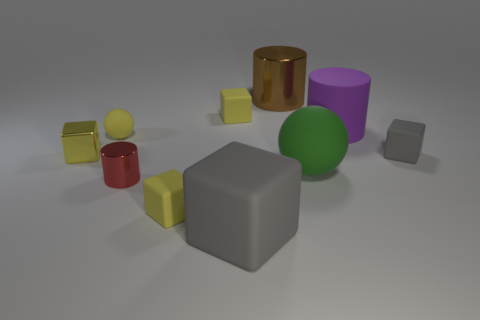Subtract all yellow blocks. How many were subtracted if there are1yellow blocks left? 2 Subtract all small gray rubber blocks. How many blocks are left? 4 Subtract all red balls. How many yellow blocks are left? 3 Subtract all gray blocks. How many blocks are left? 3 Subtract all balls. How many objects are left? 8 Subtract all gray cylinders. Subtract all brown blocks. How many cylinders are left? 3 Subtract 0 red balls. How many objects are left? 10 Subtract all matte things. Subtract all large purple things. How many objects are left? 2 Add 6 tiny metallic cylinders. How many tiny metallic cylinders are left? 7 Add 4 gray rubber blocks. How many gray rubber blocks exist? 6 